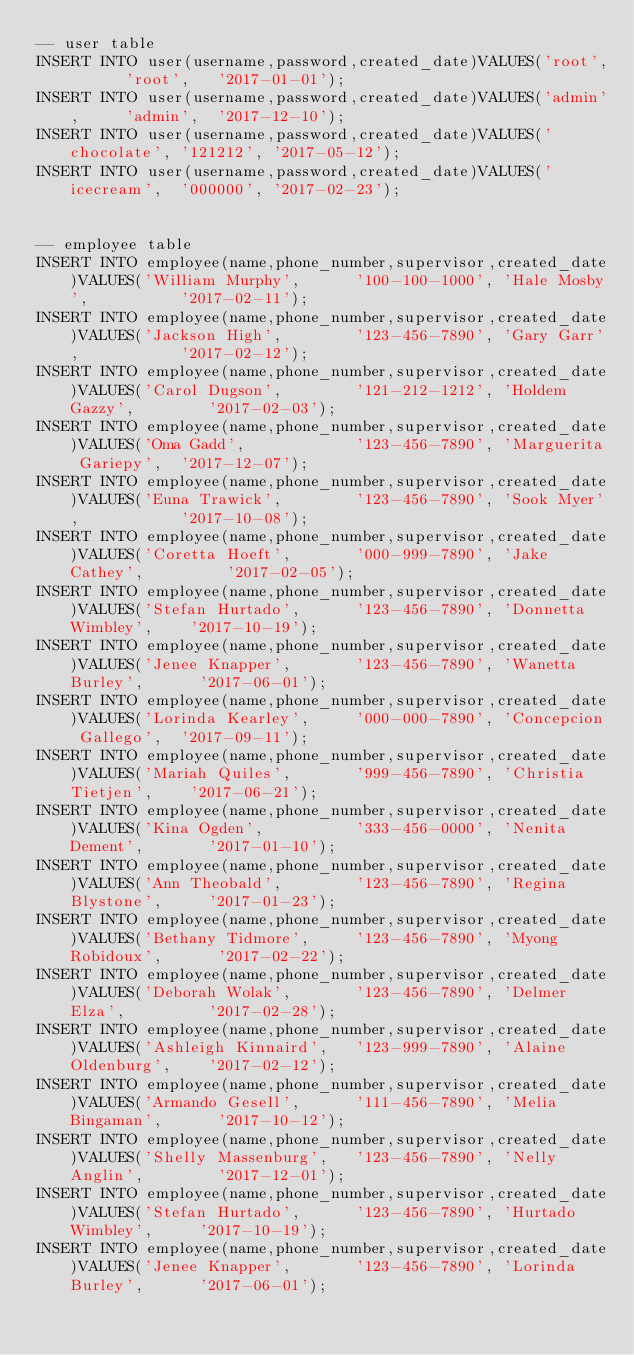<code> <loc_0><loc_0><loc_500><loc_500><_SQL_>-- user table
INSERT INTO user(username,password,created_date)VALUES('root',      'root',   '2017-01-01');
INSERT INTO user(username,password,created_date)VALUES('admin',     'admin',  '2017-12-10');
INSERT INTO user(username,password,created_date)VALUES('chocolate', '121212', '2017-05-12');
INSERT INTO user(username,password,created_date)VALUES('icecream',  '000000', '2017-02-23');


-- employee table
INSERT INTO employee(name,phone_number,supervisor,created_date)VALUES('William Murphy',      '100-100-1000', 'Hale Mosby',          '2017-02-11');
INSERT INTO employee(name,phone_number,supervisor,created_date)VALUES('Jackson High',        '123-456-7890', 'Gary Garr',           '2017-02-12');
INSERT INTO employee(name,phone_number,supervisor,created_date)VALUES('Carol Dugson',        '121-212-1212', 'Holdem Gazzy',        '2017-02-03');
INSERT INTO employee(name,phone_number,supervisor,created_date)VALUES('Oma Gadd',            '123-456-7890', 'Marguerita Gariepy',  '2017-12-07');
INSERT INTO employee(name,phone_number,supervisor,created_date)VALUES('Euna Trawick',        '123-456-7890', 'Sook Myer',           '2017-10-08');
INSERT INTO employee(name,phone_number,supervisor,created_date)VALUES('Coretta Hoeft',       '000-999-7890', 'Jake Cathey',         '2017-02-05');
INSERT INTO employee(name,phone_number,supervisor,created_date)VALUES('Stefan Hurtado',      '123-456-7890', 'Donnetta Wimbley',    '2017-10-19');
INSERT INTO employee(name,phone_number,supervisor,created_date)VALUES('Jenee Knapper',       '123-456-7890', 'Wanetta Burley',      '2017-06-01');
INSERT INTO employee(name,phone_number,supervisor,created_date)VALUES('Lorinda Kearley',     '000-000-7890', 'Concepcion Gallego',  '2017-09-11');
INSERT INTO employee(name,phone_number,supervisor,created_date)VALUES('Mariah Quiles',       '999-456-7890', 'Christia Tietjen',    '2017-06-21');
INSERT INTO employee(name,phone_number,supervisor,created_date)VALUES('Kina Ogden',          '333-456-0000', 'Nenita Dement',       '2017-01-10');
INSERT INTO employee(name,phone_number,supervisor,created_date)VALUES('Ann Theobald',        '123-456-7890', 'Regina Blystone',     '2017-01-23');
INSERT INTO employee(name,phone_number,supervisor,created_date)VALUES('Bethany Tidmore',     '123-456-7890', 'Myong Robidoux',      '2017-02-22');
INSERT INTO employee(name,phone_number,supervisor,created_date)VALUES('Deborah Wolak',       '123-456-7890', 'Delmer Elza',         '2017-02-28');
INSERT INTO employee(name,phone_number,supervisor,created_date)VALUES('Ashleigh Kinnaird',   '123-999-7890', 'Alaine Oldenburg',    '2017-02-12');
INSERT INTO employee(name,phone_number,supervisor,created_date)VALUES('Armando Gesell',      '111-456-7890', 'Melia Bingaman',      '2017-10-12');
INSERT INTO employee(name,phone_number,supervisor,created_date)VALUES('Shelly Massenburg',   '123-456-7890', 'Nelly Anglin',        '2017-12-01');
INSERT INTO employee(name,phone_number,supervisor,created_date)VALUES('Stefan Hurtado',      '123-456-7890', 'Hurtado Wimbley',     '2017-10-19');
INSERT INTO employee(name,phone_number,supervisor,created_date)VALUES('Jenee Knapper',       '123-456-7890', 'Lorinda Burley',      '2017-06-01');</code> 